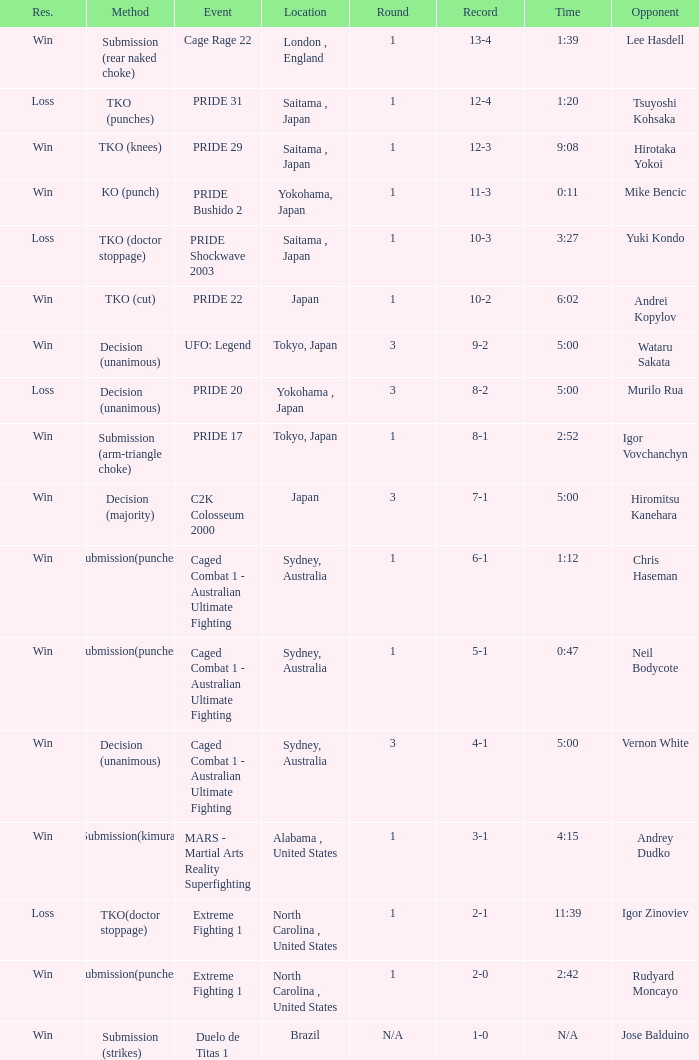Which Record has the Res of win with the Event of extreme fighting 1? 2-0. Could you parse the entire table? {'header': ['Res.', 'Method', 'Event', 'Location', 'Round', 'Record', 'Time', 'Opponent'], 'rows': [['Win', 'Submission (rear naked choke)', 'Cage Rage 22', 'London , England', '1', '13-4', '1:39', 'Lee Hasdell'], ['Loss', 'TKO (punches)', 'PRIDE 31', 'Saitama , Japan', '1', '12-4', '1:20', 'Tsuyoshi Kohsaka'], ['Win', 'TKO (knees)', 'PRIDE 29', 'Saitama , Japan', '1', '12-3', '9:08', 'Hirotaka Yokoi'], ['Win', 'KO (punch)', 'PRIDE Bushido 2', 'Yokohama, Japan', '1', '11-3', '0:11', 'Mike Bencic'], ['Loss', 'TKO (doctor stoppage)', 'PRIDE Shockwave 2003', 'Saitama , Japan', '1', '10-3', '3:27', 'Yuki Kondo'], ['Win', 'TKO (cut)', 'PRIDE 22', 'Japan', '1', '10-2', '6:02', 'Andrei Kopylov'], ['Win', 'Decision (unanimous)', 'UFO: Legend', 'Tokyo, Japan', '3', '9-2', '5:00', 'Wataru Sakata'], ['Loss', 'Decision (unanimous)', 'PRIDE 20', 'Yokohama , Japan', '3', '8-2', '5:00', 'Murilo Rua'], ['Win', 'Submission (arm-triangle choke)', 'PRIDE 17', 'Tokyo, Japan', '1', '8-1', '2:52', 'Igor Vovchanchyn'], ['Win', 'Decision (majority)', 'C2K Colosseum 2000', 'Japan', '3', '7-1', '5:00', 'Hiromitsu Kanehara'], ['Win', 'Submission(punches)', 'Caged Combat 1 - Australian Ultimate Fighting', 'Sydney, Australia', '1', '6-1', '1:12', 'Chris Haseman'], ['Win', 'Submission(punches)', 'Caged Combat 1 - Australian Ultimate Fighting', 'Sydney, Australia', '1', '5-1', '0:47', 'Neil Bodycote'], ['Win', 'Decision (unanimous)', 'Caged Combat 1 - Australian Ultimate Fighting', 'Sydney, Australia', '3', '4-1', '5:00', 'Vernon White'], ['Win', 'Submission(kimura)', 'MARS - Martial Arts Reality Superfighting', 'Alabama , United States', '1', '3-1', '4:15', 'Andrey Dudko'], ['Loss', 'TKO(doctor stoppage)', 'Extreme Fighting 1', 'North Carolina , United States', '1', '2-1', '11:39', 'Igor Zinoviev'], ['Win', 'Submission(punches)', 'Extreme Fighting 1', 'North Carolina , United States', '1', '2-0', '2:42', 'Rudyard Moncayo'], ['Win', 'Submission (strikes)', 'Duelo de Titas 1', 'Brazil', 'N/A', '1-0', 'N/A', 'Jose Balduino']]} 